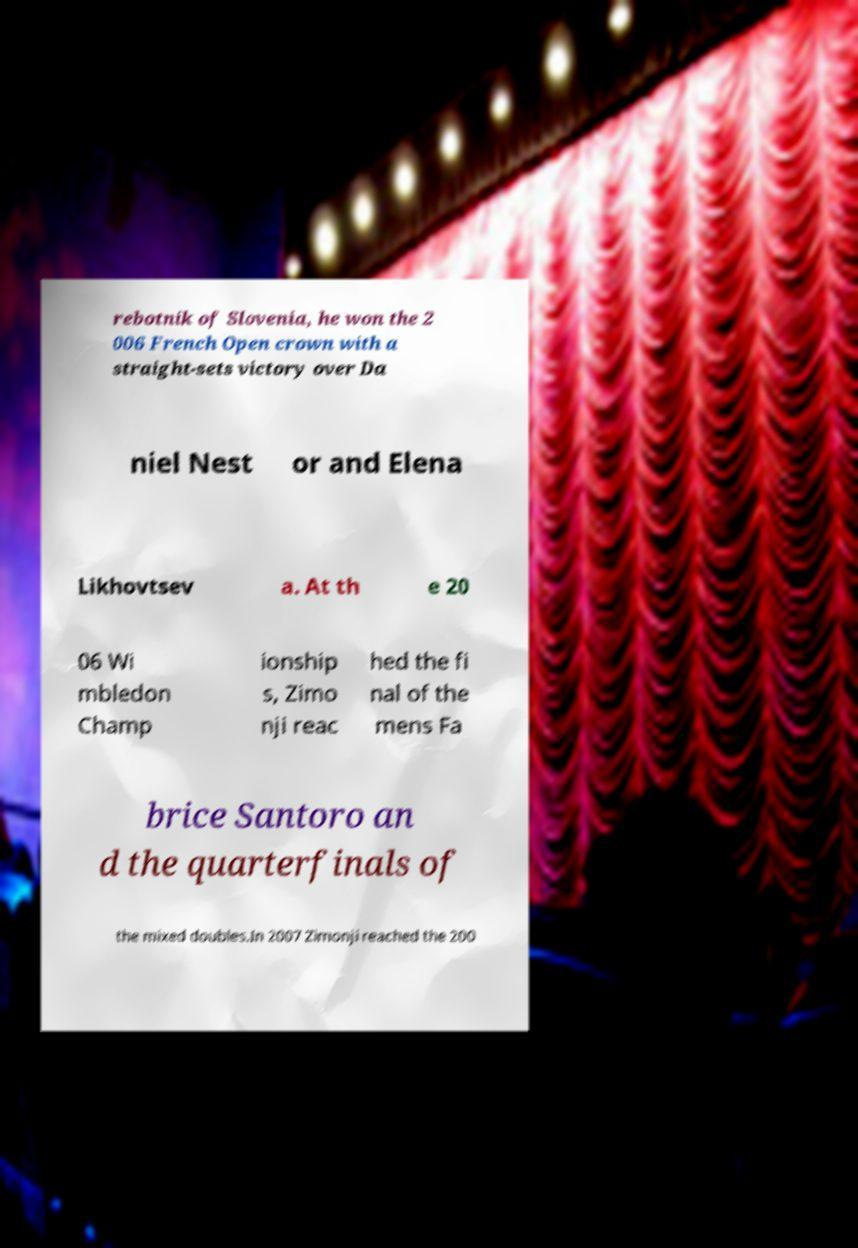Please read and relay the text visible in this image. What does it say? rebotnik of Slovenia, he won the 2 006 French Open crown with a straight-sets victory over Da niel Nest or and Elena Likhovtsev a. At th e 20 06 Wi mbledon Champ ionship s, Zimo nji reac hed the fi nal of the mens Fa brice Santoro an d the quarterfinals of the mixed doubles.In 2007 Zimonji reached the 200 